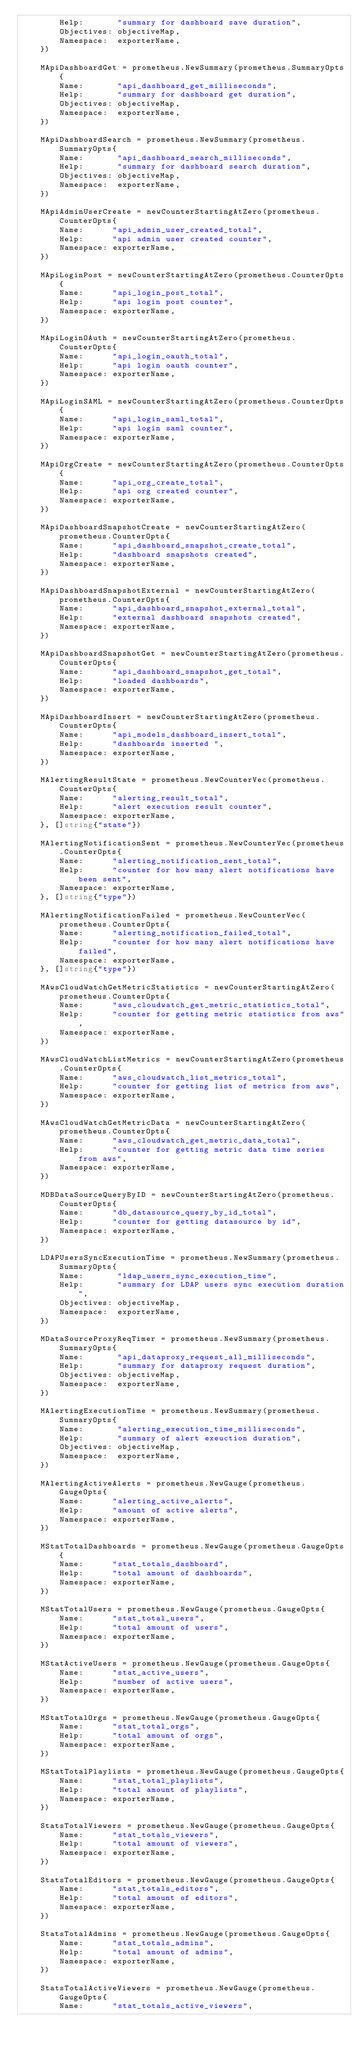Convert code to text. <code><loc_0><loc_0><loc_500><loc_500><_Go_>		Help:       "summary for dashboard save duration",
		Objectives: objectiveMap,
		Namespace:  exporterName,
	})

	MApiDashboardGet = prometheus.NewSummary(prometheus.SummaryOpts{
		Name:       "api_dashboard_get_milliseconds",
		Help:       "summary for dashboard get duration",
		Objectives: objectiveMap,
		Namespace:  exporterName,
	})

	MApiDashboardSearch = prometheus.NewSummary(prometheus.SummaryOpts{
		Name:       "api_dashboard_search_milliseconds",
		Help:       "summary for dashboard search duration",
		Objectives: objectiveMap,
		Namespace:  exporterName,
	})

	MApiAdminUserCreate = newCounterStartingAtZero(prometheus.CounterOpts{
		Name:      "api_admin_user_created_total",
		Help:      "api admin user created counter",
		Namespace: exporterName,
	})

	MApiLoginPost = newCounterStartingAtZero(prometheus.CounterOpts{
		Name:      "api_login_post_total",
		Help:      "api login post counter",
		Namespace: exporterName,
	})

	MApiLoginOAuth = newCounterStartingAtZero(prometheus.CounterOpts{
		Name:      "api_login_oauth_total",
		Help:      "api login oauth counter",
		Namespace: exporterName,
	})

	MApiLoginSAML = newCounterStartingAtZero(prometheus.CounterOpts{
		Name:      "api_login_saml_total",
		Help:      "api login saml counter",
		Namespace: exporterName,
	})

	MApiOrgCreate = newCounterStartingAtZero(prometheus.CounterOpts{
		Name:      "api_org_create_total",
		Help:      "api org created counter",
		Namespace: exporterName,
	})

	MApiDashboardSnapshotCreate = newCounterStartingAtZero(prometheus.CounterOpts{
		Name:      "api_dashboard_snapshot_create_total",
		Help:      "dashboard snapshots created",
		Namespace: exporterName,
	})

	MApiDashboardSnapshotExternal = newCounterStartingAtZero(prometheus.CounterOpts{
		Name:      "api_dashboard_snapshot_external_total",
		Help:      "external dashboard snapshots created",
		Namespace: exporterName,
	})

	MApiDashboardSnapshotGet = newCounterStartingAtZero(prometheus.CounterOpts{
		Name:      "api_dashboard_snapshot_get_total",
		Help:      "loaded dashboards",
		Namespace: exporterName,
	})

	MApiDashboardInsert = newCounterStartingAtZero(prometheus.CounterOpts{
		Name:      "api_models_dashboard_insert_total",
		Help:      "dashboards inserted ",
		Namespace: exporterName,
	})

	MAlertingResultState = prometheus.NewCounterVec(prometheus.CounterOpts{
		Name:      "alerting_result_total",
		Help:      "alert execution result counter",
		Namespace: exporterName,
	}, []string{"state"})

	MAlertingNotificationSent = prometheus.NewCounterVec(prometheus.CounterOpts{
		Name:      "alerting_notification_sent_total",
		Help:      "counter for how many alert notifications have been sent",
		Namespace: exporterName,
	}, []string{"type"})

	MAlertingNotificationFailed = prometheus.NewCounterVec(prometheus.CounterOpts{
		Name:      "alerting_notification_failed_total",
		Help:      "counter for how many alert notifications have failed",
		Namespace: exporterName,
	}, []string{"type"})

	MAwsCloudWatchGetMetricStatistics = newCounterStartingAtZero(prometheus.CounterOpts{
		Name:      "aws_cloudwatch_get_metric_statistics_total",
		Help:      "counter for getting metric statistics from aws",
		Namespace: exporterName,
	})

	MAwsCloudWatchListMetrics = newCounterStartingAtZero(prometheus.CounterOpts{
		Name:      "aws_cloudwatch_list_metrics_total",
		Help:      "counter for getting list of metrics from aws",
		Namespace: exporterName,
	})

	MAwsCloudWatchGetMetricData = newCounterStartingAtZero(prometheus.CounterOpts{
		Name:      "aws_cloudwatch_get_metric_data_total",
		Help:      "counter for getting metric data time series from aws",
		Namespace: exporterName,
	})

	MDBDataSourceQueryByID = newCounterStartingAtZero(prometheus.CounterOpts{
		Name:      "db_datasource_query_by_id_total",
		Help:      "counter for getting datasource by id",
		Namespace: exporterName,
	})

	LDAPUsersSyncExecutionTime = prometheus.NewSummary(prometheus.SummaryOpts{
		Name:       "ldap_users_sync_execution_time",
		Help:       "summary for LDAP users sync execution duration",
		Objectives: objectiveMap,
		Namespace:  exporterName,
	})

	MDataSourceProxyReqTimer = prometheus.NewSummary(prometheus.SummaryOpts{
		Name:       "api_dataproxy_request_all_milliseconds",
		Help:       "summary for dataproxy request duration",
		Objectives: objectiveMap,
		Namespace:  exporterName,
	})

	MAlertingExecutionTime = prometheus.NewSummary(prometheus.SummaryOpts{
		Name:       "alerting_execution_time_milliseconds",
		Help:       "summary of alert exeuction duration",
		Objectives: objectiveMap,
		Namespace:  exporterName,
	})

	MAlertingActiveAlerts = prometheus.NewGauge(prometheus.GaugeOpts{
		Name:      "alerting_active_alerts",
		Help:      "amount of active alerts",
		Namespace: exporterName,
	})

	MStatTotalDashboards = prometheus.NewGauge(prometheus.GaugeOpts{
		Name:      "stat_totals_dashboard",
		Help:      "total amount of dashboards",
		Namespace: exporterName,
	})

	MStatTotalUsers = prometheus.NewGauge(prometheus.GaugeOpts{
		Name:      "stat_total_users",
		Help:      "total amount of users",
		Namespace: exporterName,
	})

	MStatActiveUsers = prometheus.NewGauge(prometheus.GaugeOpts{
		Name:      "stat_active_users",
		Help:      "number of active users",
		Namespace: exporterName,
	})

	MStatTotalOrgs = prometheus.NewGauge(prometheus.GaugeOpts{
		Name:      "stat_total_orgs",
		Help:      "total amount of orgs",
		Namespace: exporterName,
	})

	MStatTotalPlaylists = prometheus.NewGauge(prometheus.GaugeOpts{
		Name:      "stat_total_playlists",
		Help:      "total amount of playlists",
		Namespace: exporterName,
	})

	StatsTotalViewers = prometheus.NewGauge(prometheus.GaugeOpts{
		Name:      "stat_totals_viewers",
		Help:      "total amount of viewers",
		Namespace: exporterName,
	})

	StatsTotalEditors = prometheus.NewGauge(prometheus.GaugeOpts{
		Name:      "stat_totals_editors",
		Help:      "total amount of editors",
		Namespace: exporterName,
	})

	StatsTotalAdmins = prometheus.NewGauge(prometheus.GaugeOpts{
		Name:      "stat_totals_admins",
		Help:      "total amount of admins",
		Namespace: exporterName,
	})

	StatsTotalActiveViewers = prometheus.NewGauge(prometheus.GaugeOpts{
		Name:      "stat_totals_active_viewers",</code> 